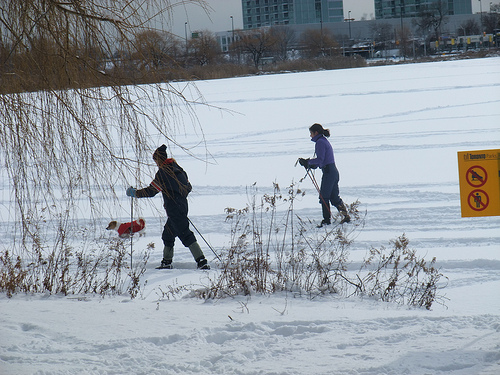How many kids? 2 